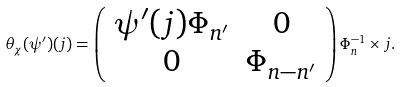Convert formula to latex. <formula><loc_0><loc_0><loc_500><loc_500>\theta _ { \chi } ( \psi ^ { \prime } ) ( j ) = \left ( \begin{array} { c c } \psi ^ { \prime } ( j ) \Phi _ { n ^ { \prime } } & 0 \\ 0 & \Phi _ { n - n ^ { \prime } } \end{array} \right ) \Phi _ { n } ^ { - 1 } \times j .</formula> 